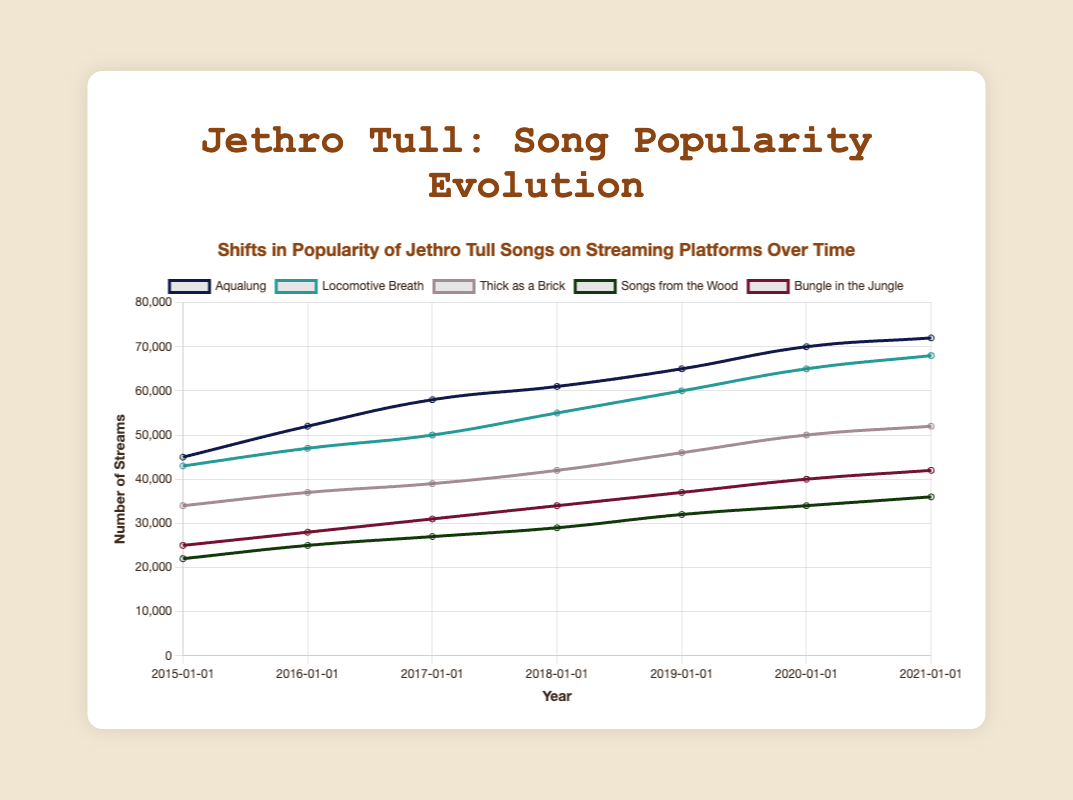How has the popularity of "Aqualung" changed from 2015 to 2021? The plot shows the y-values for each year corresponding to the number of streams of "Aqualung" from 2015 to 2021. In 2015, it starts at 45,000 streams and ends at 72,000 streams in 2021, showing a consistent increase.
Answer: Increased Which song had the highest number of streams in 2021? To answer this, we need to look at the data points for 2021 and identify the highest y-value (number of streams). The highest data point belongs to "Aqualung" with 72,000 streams.
Answer: "Aqualung" Between "Locomotive Breath" and "Thick as a Brick", which song showed a greater increase in popularity from 2015 to 2021? We first calculate the difference in streams for each song between 2015 and 2021. "Locomotive Breath" went from 43,000 to 68,000 streams, an increase of 25,000. "Thick as a Brick" went from 34,000 to 52,000 streams, an increase of 18,000. Comparing the two, "Locomotive Breath" shows a greater increase.
Answer: "Locomotive Breath" Which song had the lowest number of streams in 2015? Refer to the data points for 2015 and identify the smallest y-value. "Songs from the Wood" had the lowest number of streams in 2015 with 22,000 streams.
Answer: "Songs from the Wood" On average, what was the yearly increase in streams for "Bungle in the Jungle" from 2015 to 2021? Calculate the total increase in streams from 2015 (25,000) to 2021 (42,000) which is 17,000. This change occurred over 6 years, so the average yearly increase would be 17,000 / 6 = 2833.33 streams per year.
Answer: Approximately 2833.33 streams/year What was the total number of streams for "Songs from the Wood" over all the years shown? Calculate the sum of the number of streams for "Songs from the Wood" from 2015 to 2021: 22,000 + 25,000 + 27,000 + 29,000 + 32,000 + 34,000 + 36,000 = 205,000 streams.
Answer: 205,000 streams Comparing "Aqualung" and "Locomotive Breath", which song had a higher number of streams in 2018, and by how much? In 2018, "Aqualung" had 61,000 streams and "Locomotive Breath" had 55,000 streams. Subtract the smaller number from the larger number: 61,000 - 55,000 = 6,000 streams.
Answer: "Aqualung" by 6,000 streams 